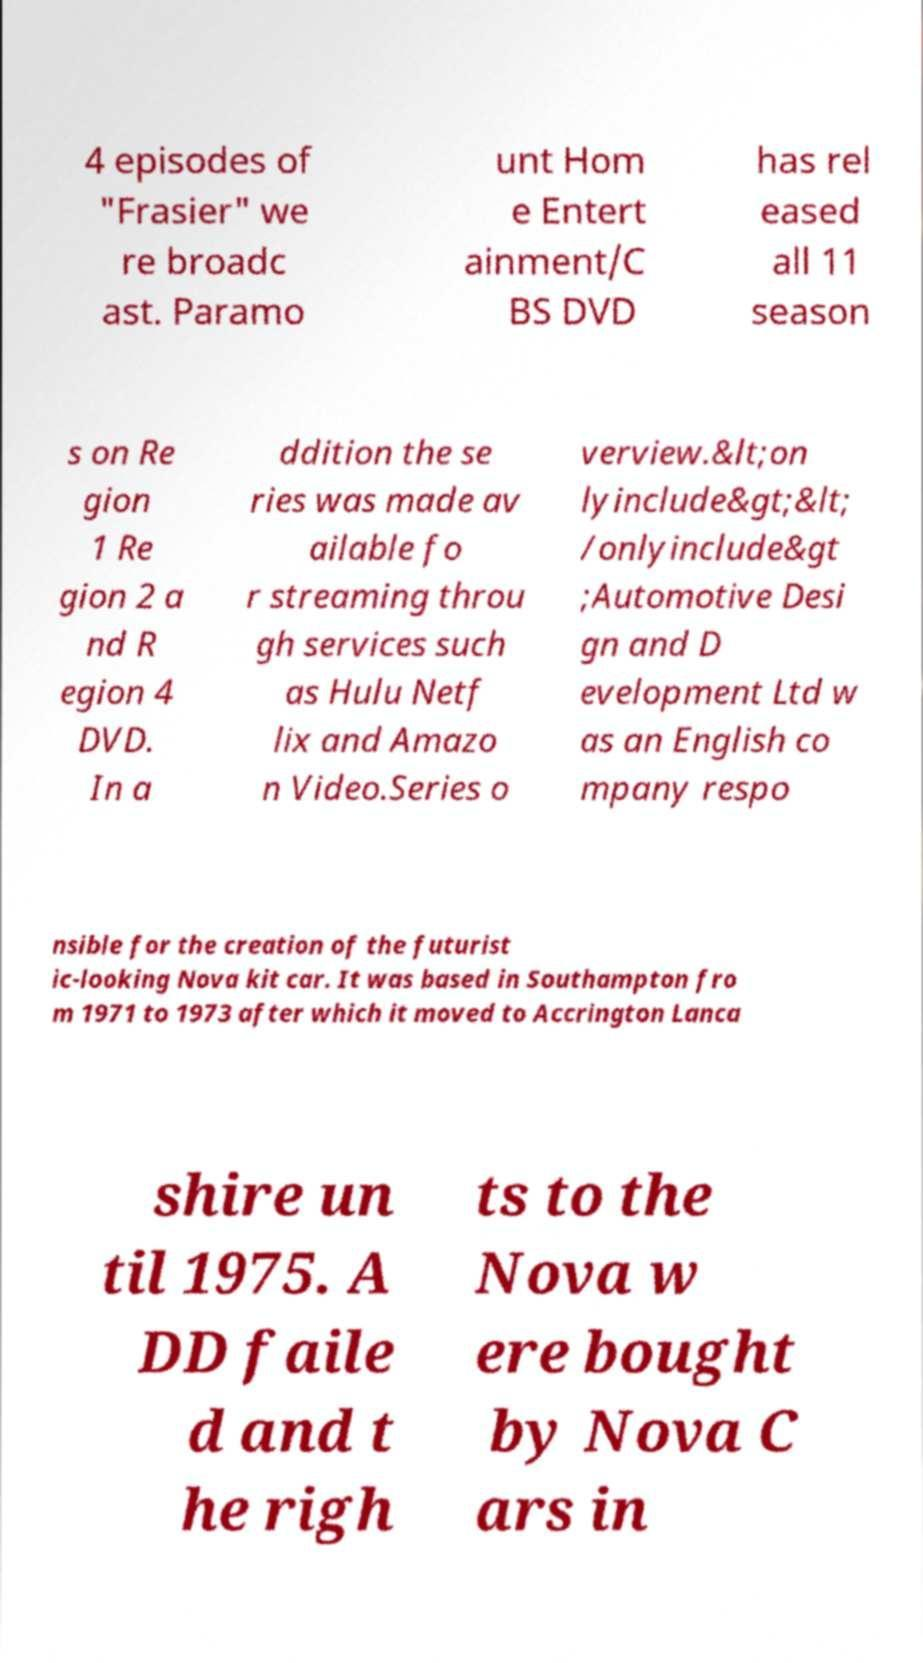There's text embedded in this image that I need extracted. Can you transcribe it verbatim? 4 episodes of "Frasier" we re broadc ast. Paramo unt Hom e Entert ainment/C BS DVD has rel eased all 11 season s on Re gion 1 Re gion 2 a nd R egion 4 DVD. In a ddition the se ries was made av ailable fo r streaming throu gh services such as Hulu Netf lix and Amazo n Video.Series o verview.&lt;on lyinclude&gt;&lt; /onlyinclude&gt ;Automotive Desi gn and D evelopment Ltd w as an English co mpany respo nsible for the creation of the futurist ic-looking Nova kit car. It was based in Southampton fro m 1971 to 1973 after which it moved to Accrington Lanca shire un til 1975. A DD faile d and t he righ ts to the Nova w ere bought by Nova C ars in 